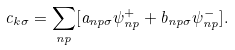<formula> <loc_0><loc_0><loc_500><loc_500>c _ { { k } \sigma } = \sum _ { n p } [ a _ { n p \sigma } \psi _ { n p } ^ { + } + b _ { n p \sigma } \psi _ { n p } ^ { - } ] .</formula> 